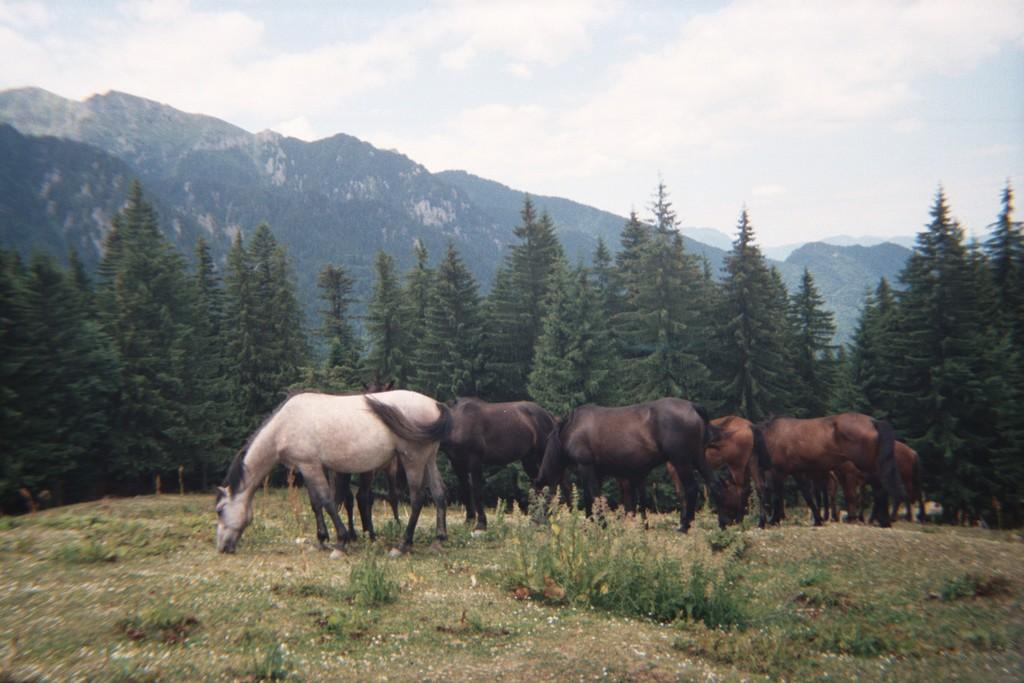What types of living organisms can be seen in the image? There are animals in the image. What is visible beneath the animals' feet in the image? The ground is visible in the image. What type of vegetation is present in the image? There is grass, plants, and trees in the image. What is the terrain like in the image? There are hills in the image. What part of the natural environment is visible in the image? The sky is visible in the image, and clouds are present in the sky. What type of eggnog can be seen in the image? There is no eggnog present in the image. How many pies are visible in the image? There are no pies visible in the image. 